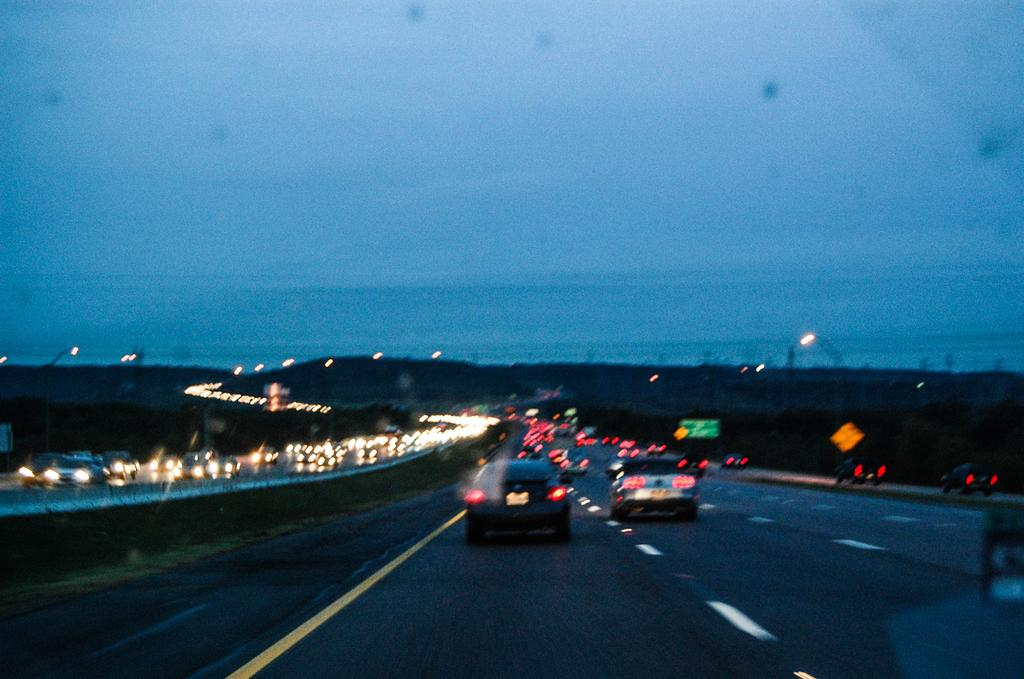What can be seen on the road in the image? There are vehicles on the road in the image. What else is visible in the image besides the vehicles? There are lights and sign boards visible in the image. What can be seen in the background of the image? The sky is visible in the background of the image. What type of corn is being sold on the street in the image? There is no corn or street present in the image; it features vehicles on a road with lights and sign boards. Can you hear a whistle in the image? There is no whistle present in the image; it is a visual representation of vehicles, lights, sign boards, and the sky. 